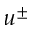Convert formula to latex. <formula><loc_0><loc_0><loc_500><loc_500>u ^ { \pm }</formula> 